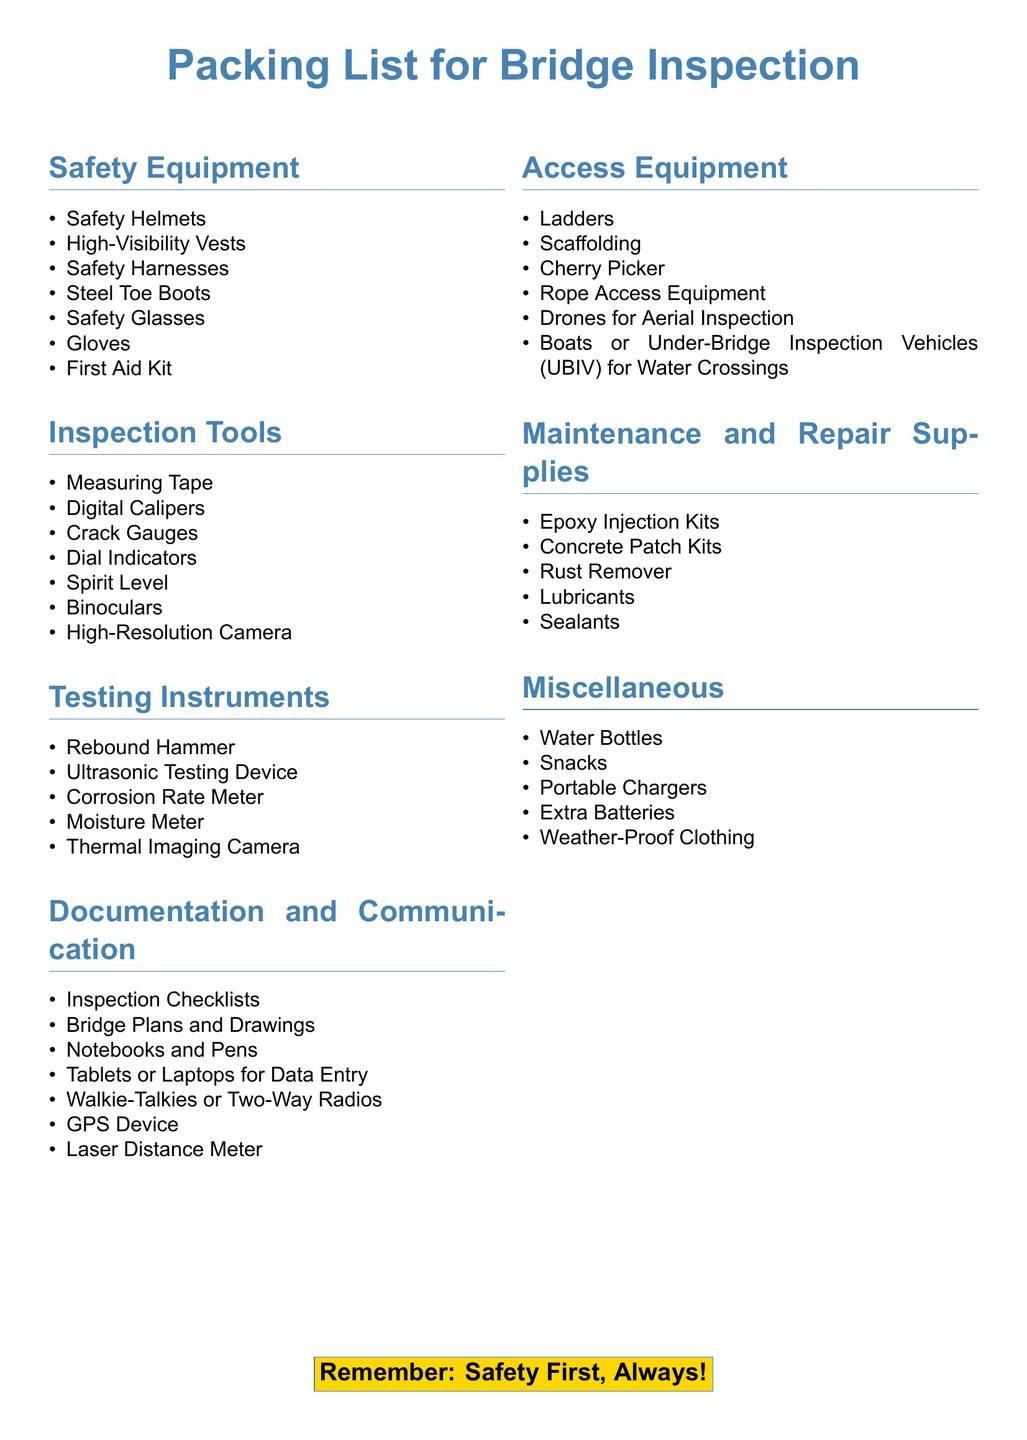What is included in the safety equipment? The safety equipment list contains items such as Safety Helmets, High-Visibility Vests, Safety Harnesses, Steel Toe Boots, Safety Glasses, Gloves, and a First Aid Kit.
Answer: Safety Helmets, High-Visibility Vests, Safety Harnesses, Steel Toe Boots, Safety Glasses, Gloves, First Aid Kit How many types of inspection tools are listed? The document enumerates seven different inspection tools, listed under the "Inspection Tools" section.
Answer: Seven What testing instrument is used for measuring corrosion? The document specifies a Corrosion Rate Meter as the instrument for measuring corrosion.
Answer: Corrosion Rate Meter What type of equipment can be used for aerial inspection? Drones for Aerial Inspection are specifically mentioned in the Access Equipment section for aerial inspections.
Answer: Drones for Aerial Inspection What are the two types of communication devices listed? The document mentions Walkie-Talkies or Two-Way Radios for communication purposes.
Answer: Walkie-Talkies, Two-Way Radios How many items are listed under Maintenance and Repair Supplies? There are five items listed under the Maintenance and Repair Supplies section of the document.
Answer: Five What should you remember according to the document? At the end of the document, it emphasizes the importance of safety with the phrase "Safety First, Always!"
Answer: Safety First, Always! What are two items listed in the Miscellaneous section? The Miscellaneous section includes items such as Water Bottles and Snacks.
Answer: Water Bottles, Snacks 